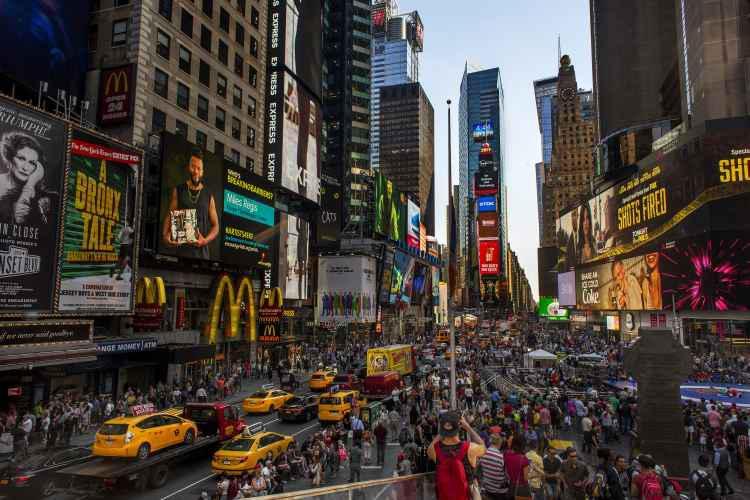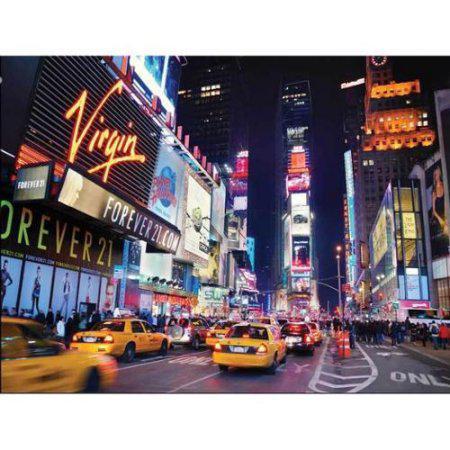The first image is the image on the left, the second image is the image on the right. Assess this claim about the two images: "There are at least four yellow taxi cabs.". Correct or not? Answer yes or no. Yes. The first image is the image on the left, the second image is the image on the right. Considering the images on both sides, is "It is night in the right image, with lots of lit up buildings." valid? Answer yes or no. Yes. 